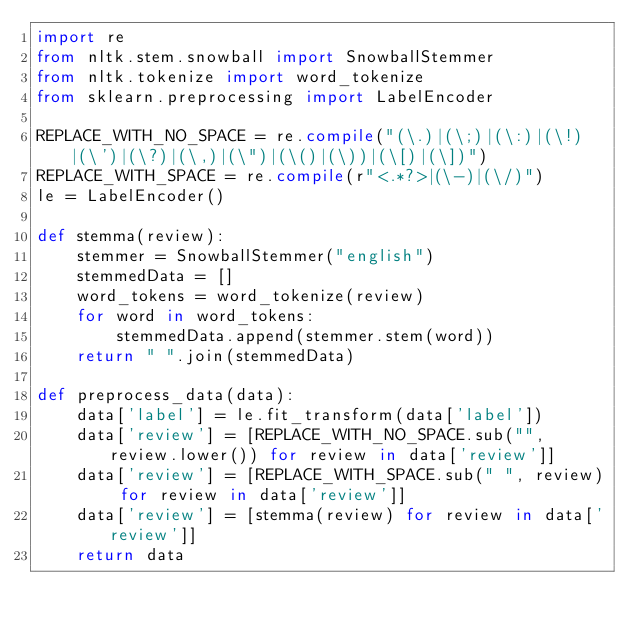<code> <loc_0><loc_0><loc_500><loc_500><_Python_>import re
from nltk.stem.snowball import SnowballStemmer
from nltk.tokenize import word_tokenize
from sklearn.preprocessing import LabelEncoder

REPLACE_WITH_NO_SPACE = re.compile("(\.)|(\;)|(\:)|(\!)|(\')|(\?)|(\,)|(\")|(\()|(\))|(\[)|(\])")
REPLACE_WITH_SPACE = re.compile(r"<.*?>|(\-)|(\/)")
le = LabelEncoder()

def stemma(review):
    stemmer = SnowballStemmer("english")
    stemmedData = []
    word_tokens = word_tokenize(review)
    for word in word_tokens:
        stemmedData.append(stemmer.stem(word))
    return " ".join(stemmedData)

def preprocess_data(data):
    data['label'] = le.fit_transform(data['label'])
    data['review'] = [REPLACE_WITH_NO_SPACE.sub("", review.lower()) for review in data['review']]
    data['review'] = [REPLACE_WITH_SPACE.sub(" ", review) for review in data['review']]
    data['review'] = [stemma(review) for review in data['review']]
    return data</code> 